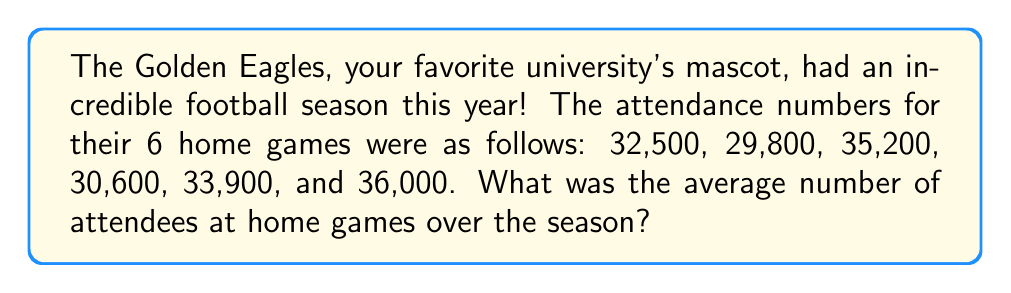What is the answer to this math problem? To find the average number of attendees at home games over the season, we need to:

1. Sum up the total attendance for all home games
2. Divide the total by the number of home games

Let's break it down step-by-step:

1. Sum of attendees:
   $32,500 + 29,800 + 35,200 + 30,600 + 33,900 + 36,000 = 198,000$

2. Number of home games: 6

3. Calculate the average:
   $$\text{Average} = \frac{\text{Sum of attendees}}{\text{Number of games}}$$
   $$\text{Average} = \frac{198,000}{6}$$
   $$\text{Average} = 33,000$$

Therefore, the average number of attendees at home games over the season was 33,000.
Answer: $33,000$ attendees 